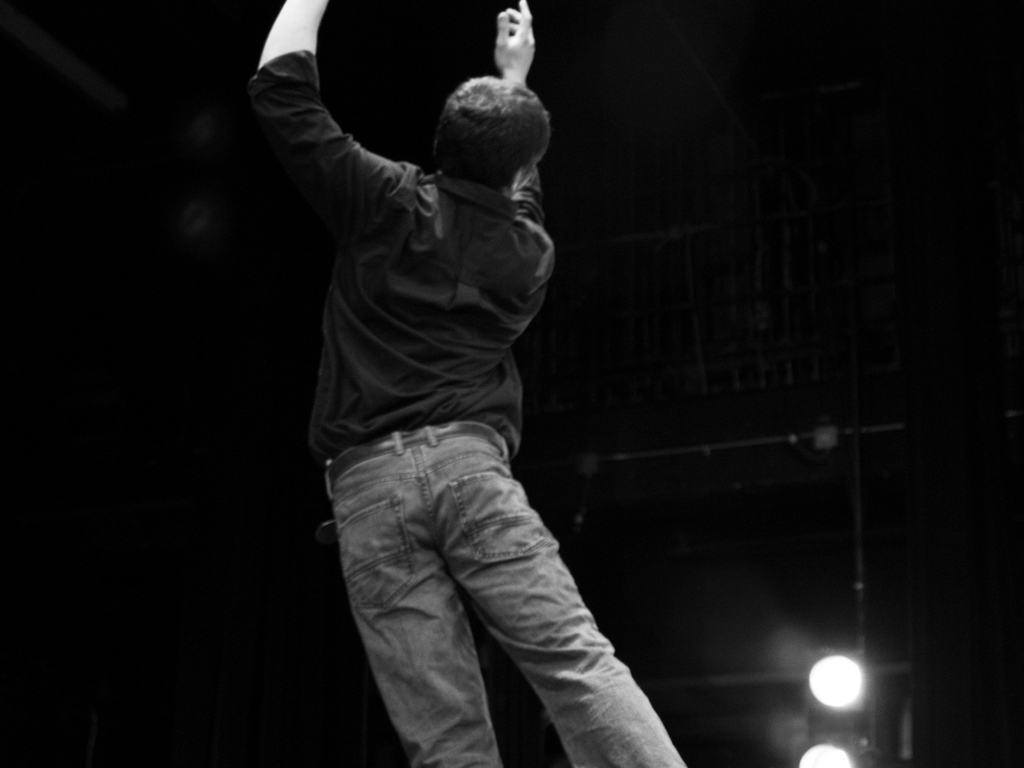Is there noise in the bottom right corner? Upon reviewing the bottom right corner of the image, it does appear that there is some level of graininess or noise present. This could be due to low lighting conditions or high ISO settings used during the capture of the photograph. 